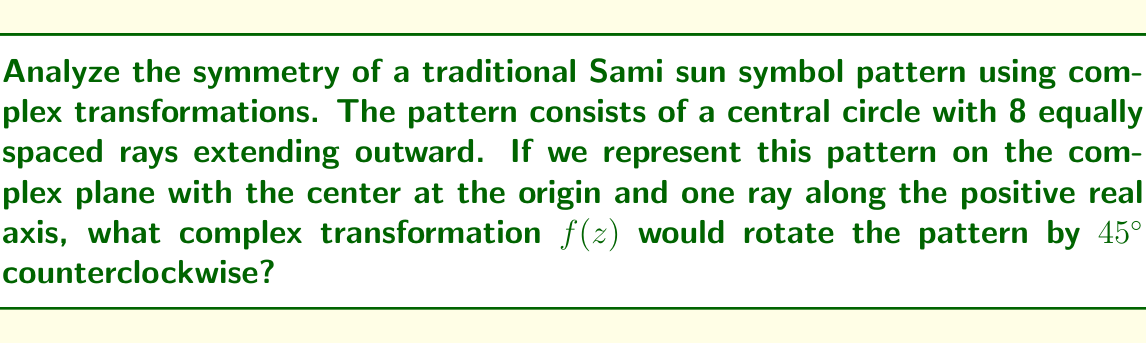Help me with this question. To solve this problem, we need to consider the following steps:

1) In the complex plane, a rotation by an angle $\theta$ counterclockwise around the origin is represented by the transformation:

   $f(z) = e^{i\theta} z$

2) In this case, we want to rotate by 45° counterclockwise. We need to convert 45° to radians:

   $45° = \frac{45 \pi}{180} = \frac{\pi}{4}$ radians

3) Therefore, the complex transformation we're looking for is:

   $f(z) = e^{i\frac{\pi}{4}} z$

4) We can simplify this further using Euler's formula:

   $e^{i\theta} = \cos\theta + i\sin\theta$

5) For $\theta = \frac{\pi}{4}$:

   $\cos\frac{\pi}{4} = \sin\frac{\pi}{4} = \frac{1}{\sqrt{2}}$

6) Substituting these values:

   $f(z) = (\frac{1}{\sqrt{2}} + i\frac{1}{\sqrt{2}})z$

7) This can be further simplified to:

   $f(z) = \frac{1+i}{\sqrt{2}}z$

This transformation will rotate the Sami sun symbol by 45° counterclockwise, preserving its 8-fold rotational symmetry.
Answer: $f(z) = \frac{1+i}{\sqrt{2}}z$ 